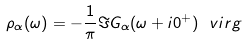<formula> <loc_0><loc_0><loc_500><loc_500>\rho _ { \alpha } ( \omega ) = - \frac { 1 } { \pi } \Im G _ { \alpha } ( \omega + i 0 ^ { + } ) \ v i r g</formula> 